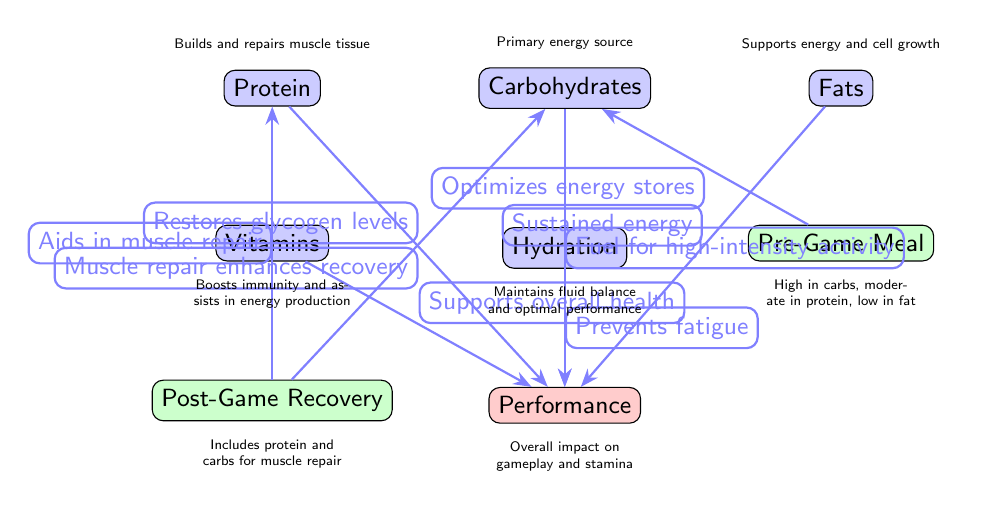What is the primary energy source in the diagram? The diagram indicates that carbohydrates are labeled as the primary energy source. When looking at the nodes, the one labeled "Carbohydrates" is associated with this specific description.
Answer: Carbohydrates How many nutrients are listed in the diagram? To find the number of nutrients, we count the individual nodes classified as nutrients: Protein, Carbohydrates, Fats, Vitamins, and Hydration, giving us a total of five nodes.
Answer: Five What does protein support in relation to performance? The diagram highlights that protein aids in muscle repair, which is a critical aspect of performance. This information can be found directly connected from the "Protein" node to the "Performance" node where its contribution is noted.
Answer: Muscle repair What relationship does the pre-game meal have with carbohydrates? The pre-game meal is connected to carbohydrates with the edge labeled "Optimizes energy stores". This indicates that the consumption of carbohydrates during the pre-game meal maximizes energy reserves for performance.
Answer: Optimizes energy stores How does hydration impact performance according to the diagram? The diagram states that hydration prevents fatigue, which directly connects hydration to performance. This relationship is highlighted by the edge from "Hydration" to "Performance" with that specific description.
Answer: Prevents fatigue Which nutrient supports overall health as shown in the diagram? The diagram clearly indicates that vitamins support overall health. This relationship is depicted in the connection from the "Vitamins" node to the "Performance" node, explicitly stating this contribution.
Answer: Vitamins What type of meal is suggested for post-game recovery? The diagram describes a post-game recovery meal that includes protein and carbs for muscle repair. This information can be found near the node labeled "Post-Game Recovery", which explains its components and significance.
Answer: Includes protein and carbs for muscle repair Which nutrient provides sustained energy according to the diagram? In reviewing the diagram, it indicates that fats provide sustained energy, connecting to the performance node with that specific description. This connection makes it clear what role fats play in performance.
Answer: Fats What does the "Post-Game Recovery" meal aid in restoring? The diagram states that the post-game recovery meal aids in restoring glycogen levels for carbohydrates, depicting this connection with an edge from the "Post-Game Recovery" node to the "Carbohydrates" node.
Answer: Restores glycogen levels 